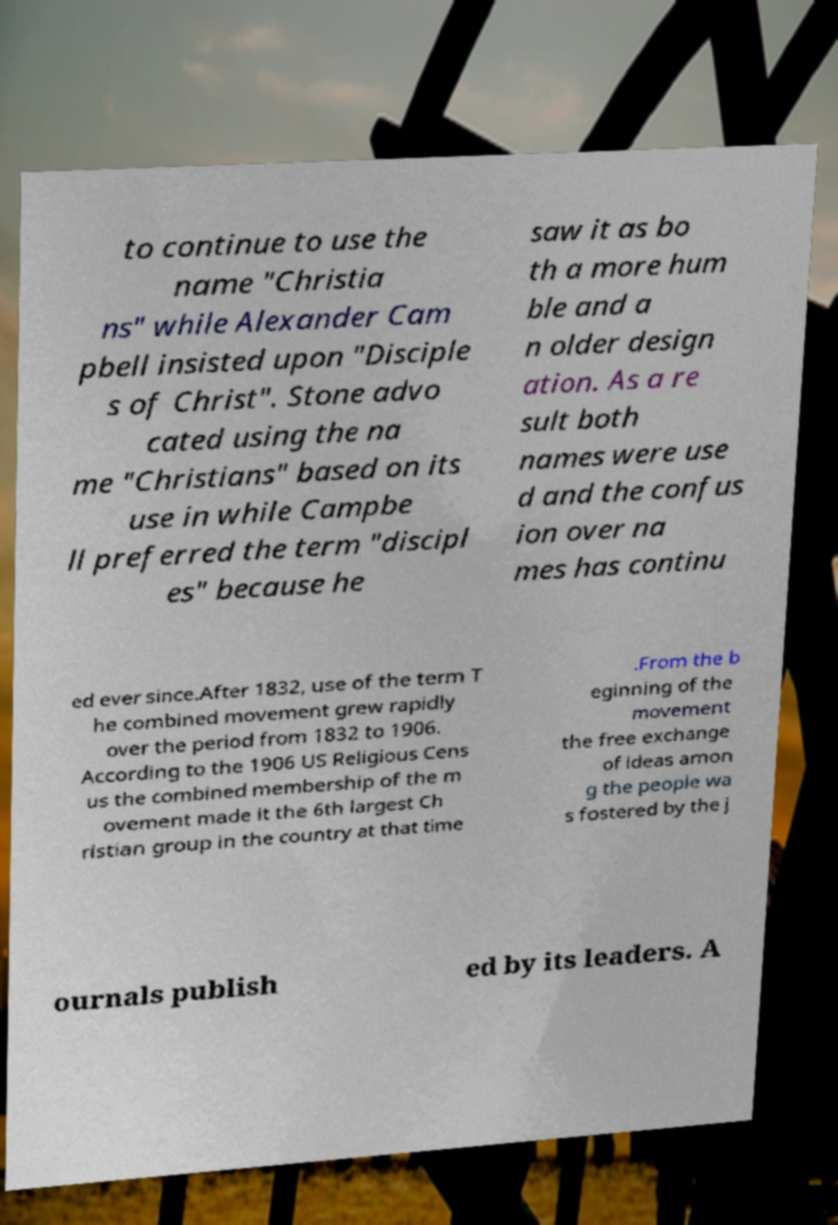Please read and relay the text visible in this image. What does it say? to continue to use the name "Christia ns" while Alexander Cam pbell insisted upon "Disciple s of Christ". Stone advo cated using the na me "Christians" based on its use in while Campbe ll preferred the term "discipl es" because he saw it as bo th a more hum ble and a n older design ation. As a re sult both names were use d and the confus ion over na mes has continu ed ever since.After 1832, use of the term T he combined movement grew rapidly over the period from 1832 to 1906. According to the 1906 US Religious Cens us the combined membership of the m ovement made it the 6th largest Ch ristian group in the country at that time .From the b eginning of the movement the free exchange of ideas amon g the people wa s fostered by the j ournals publish ed by its leaders. A 